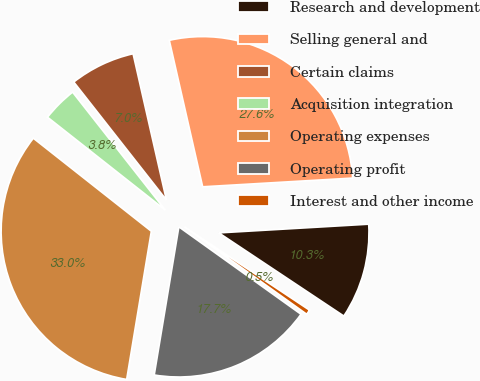Convert chart. <chart><loc_0><loc_0><loc_500><loc_500><pie_chart><fcel>Research and development<fcel>Selling general and<fcel>Certain claims<fcel>Acquisition integration<fcel>Operating expenses<fcel>Operating profit<fcel>Interest and other income<nl><fcel>10.27%<fcel>27.64%<fcel>7.03%<fcel>3.78%<fcel>33.0%<fcel>17.74%<fcel>0.54%<nl></chart> 